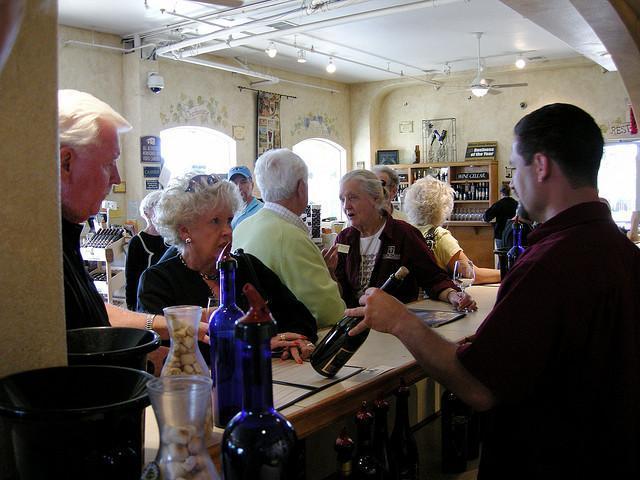How many bottles are visible?
Give a very brief answer. 5. How many people are there?
Give a very brief answer. 7. How many carrots are there?
Give a very brief answer. 0. 